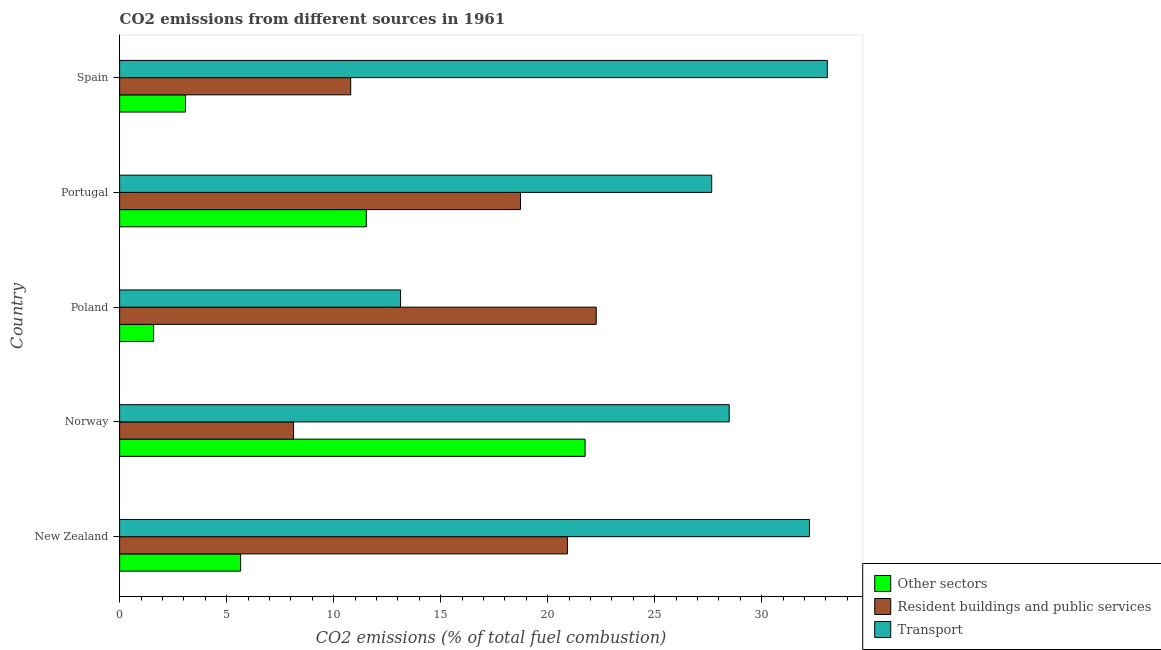How many different coloured bars are there?
Provide a succinct answer. 3. How many groups of bars are there?
Give a very brief answer. 5. How many bars are there on the 1st tick from the bottom?
Your response must be concise. 3. What is the label of the 1st group of bars from the top?
Provide a short and direct response. Spain. What is the percentage of co2 emissions from transport in Portugal?
Offer a terse response. 27.67. Across all countries, what is the maximum percentage of co2 emissions from resident buildings and public services?
Offer a very short reply. 22.27. Across all countries, what is the minimum percentage of co2 emissions from resident buildings and public services?
Your response must be concise. 8.13. What is the total percentage of co2 emissions from other sectors in the graph?
Give a very brief answer. 43.6. What is the difference between the percentage of co2 emissions from resident buildings and public services in New Zealand and that in Poland?
Provide a short and direct response. -1.35. What is the difference between the percentage of co2 emissions from resident buildings and public services in Norway and the percentage of co2 emissions from other sectors in Portugal?
Provide a short and direct response. -3.4. What is the average percentage of co2 emissions from resident buildings and public services per country?
Make the answer very short. 16.17. What is the difference between the percentage of co2 emissions from other sectors and percentage of co2 emissions from transport in Norway?
Give a very brief answer. -6.73. In how many countries, is the percentage of co2 emissions from transport greater than 4 %?
Provide a succinct answer. 5. Is the percentage of co2 emissions from other sectors in Norway less than that in Portugal?
Give a very brief answer. No. What is the difference between the highest and the second highest percentage of co2 emissions from other sectors?
Keep it short and to the point. 10.22. What is the difference between the highest and the lowest percentage of co2 emissions from transport?
Give a very brief answer. 19.94. What does the 3rd bar from the top in Norway represents?
Offer a terse response. Other sectors. What does the 3rd bar from the bottom in Spain represents?
Provide a short and direct response. Transport. What is the difference between two consecutive major ticks on the X-axis?
Your answer should be compact. 5. Are the values on the major ticks of X-axis written in scientific E-notation?
Keep it short and to the point. No. How many legend labels are there?
Provide a succinct answer. 3. What is the title of the graph?
Ensure brevity in your answer.  CO2 emissions from different sources in 1961. Does "Coal" appear as one of the legend labels in the graph?
Make the answer very short. No. What is the label or title of the X-axis?
Your response must be concise. CO2 emissions (% of total fuel combustion). What is the CO2 emissions (% of total fuel combustion) in Other sectors in New Zealand?
Offer a terse response. 5.66. What is the CO2 emissions (% of total fuel combustion) of Resident buildings and public services in New Zealand?
Make the answer very short. 20.92. What is the CO2 emissions (% of total fuel combustion) in Transport in New Zealand?
Your answer should be very brief. 32.23. What is the CO2 emissions (% of total fuel combustion) of Other sectors in Norway?
Your response must be concise. 21.75. What is the CO2 emissions (% of total fuel combustion) in Resident buildings and public services in Norway?
Provide a short and direct response. 8.13. What is the CO2 emissions (% of total fuel combustion) of Transport in Norway?
Your response must be concise. 28.48. What is the CO2 emissions (% of total fuel combustion) in Other sectors in Poland?
Your answer should be very brief. 1.59. What is the CO2 emissions (% of total fuel combustion) of Resident buildings and public services in Poland?
Provide a succinct answer. 22.27. What is the CO2 emissions (% of total fuel combustion) of Transport in Poland?
Offer a terse response. 13.13. What is the CO2 emissions (% of total fuel combustion) in Other sectors in Portugal?
Make the answer very short. 11.53. What is the CO2 emissions (% of total fuel combustion) of Resident buildings and public services in Portugal?
Give a very brief answer. 18.73. What is the CO2 emissions (% of total fuel combustion) of Transport in Portugal?
Ensure brevity in your answer.  27.67. What is the CO2 emissions (% of total fuel combustion) of Other sectors in Spain?
Provide a succinct answer. 3.08. What is the CO2 emissions (% of total fuel combustion) in Resident buildings and public services in Spain?
Offer a terse response. 10.8. What is the CO2 emissions (% of total fuel combustion) in Transport in Spain?
Give a very brief answer. 33.07. Across all countries, what is the maximum CO2 emissions (% of total fuel combustion) in Other sectors?
Provide a short and direct response. 21.75. Across all countries, what is the maximum CO2 emissions (% of total fuel combustion) in Resident buildings and public services?
Offer a terse response. 22.27. Across all countries, what is the maximum CO2 emissions (% of total fuel combustion) in Transport?
Offer a very short reply. 33.07. Across all countries, what is the minimum CO2 emissions (% of total fuel combustion) of Other sectors?
Ensure brevity in your answer.  1.59. Across all countries, what is the minimum CO2 emissions (% of total fuel combustion) of Resident buildings and public services?
Provide a short and direct response. 8.13. Across all countries, what is the minimum CO2 emissions (% of total fuel combustion) in Transport?
Provide a succinct answer. 13.13. What is the total CO2 emissions (% of total fuel combustion) of Other sectors in the graph?
Keep it short and to the point. 43.6. What is the total CO2 emissions (% of total fuel combustion) of Resident buildings and public services in the graph?
Offer a terse response. 80.85. What is the total CO2 emissions (% of total fuel combustion) in Transport in the graph?
Your answer should be compact. 134.58. What is the difference between the CO2 emissions (% of total fuel combustion) of Other sectors in New Zealand and that in Norway?
Offer a very short reply. -16.09. What is the difference between the CO2 emissions (% of total fuel combustion) in Resident buildings and public services in New Zealand and that in Norway?
Offer a very short reply. 12.8. What is the difference between the CO2 emissions (% of total fuel combustion) of Transport in New Zealand and that in Norway?
Keep it short and to the point. 3.75. What is the difference between the CO2 emissions (% of total fuel combustion) of Other sectors in New Zealand and that in Poland?
Provide a succinct answer. 4.07. What is the difference between the CO2 emissions (% of total fuel combustion) of Resident buildings and public services in New Zealand and that in Poland?
Offer a terse response. -1.35. What is the difference between the CO2 emissions (% of total fuel combustion) of Transport in New Zealand and that in Poland?
Keep it short and to the point. 19.11. What is the difference between the CO2 emissions (% of total fuel combustion) in Other sectors in New Zealand and that in Portugal?
Provide a short and direct response. -5.87. What is the difference between the CO2 emissions (% of total fuel combustion) of Resident buildings and public services in New Zealand and that in Portugal?
Keep it short and to the point. 2.19. What is the difference between the CO2 emissions (% of total fuel combustion) of Transport in New Zealand and that in Portugal?
Your answer should be very brief. 4.57. What is the difference between the CO2 emissions (% of total fuel combustion) of Other sectors in New Zealand and that in Spain?
Ensure brevity in your answer.  2.57. What is the difference between the CO2 emissions (% of total fuel combustion) of Resident buildings and public services in New Zealand and that in Spain?
Your answer should be compact. 10.13. What is the difference between the CO2 emissions (% of total fuel combustion) of Transport in New Zealand and that in Spain?
Ensure brevity in your answer.  -0.83. What is the difference between the CO2 emissions (% of total fuel combustion) of Other sectors in Norway and that in Poland?
Your answer should be compact. 20.16. What is the difference between the CO2 emissions (% of total fuel combustion) of Resident buildings and public services in Norway and that in Poland?
Give a very brief answer. -14.14. What is the difference between the CO2 emissions (% of total fuel combustion) of Transport in Norway and that in Poland?
Your response must be concise. 15.36. What is the difference between the CO2 emissions (% of total fuel combustion) in Other sectors in Norway and that in Portugal?
Make the answer very short. 10.22. What is the difference between the CO2 emissions (% of total fuel combustion) in Resident buildings and public services in Norway and that in Portugal?
Your answer should be very brief. -10.61. What is the difference between the CO2 emissions (% of total fuel combustion) in Transport in Norway and that in Portugal?
Your response must be concise. 0.82. What is the difference between the CO2 emissions (% of total fuel combustion) in Other sectors in Norway and that in Spain?
Your answer should be very brief. 18.67. What is the difference between the CO2 emissions (% of total fuel combustion) of Resident buildings and public services in Norway and that in Spain?
Offer a very short reply. -2.67. What is the difference between the CO2 emissions (% of total fuel combustion) in Transport in Norway and that in Spain?
Ensure brevity in your answer.  -4.58. What is the difference between the CO2 emissions (% of total fuel combustion) of Other sectors in Poland and that in Portugal?
Your answer should be compact. -9.94. What is the difference between the CO2 emissions (% of total fuel combustion) in Resident buildings and public services in Poland and that in Portugal?
Provide a succinct answer. 3.54. What is the difference between the CO2 emissions (% of total fuel combustion) of Transport in Poland and that in Portugal?
Offer a terse response. -14.54. What is the difference between the CO2 emissions (% of total fuel combustion) of Other sectors in Poland and that in Spain?
Ensure brevity in your answer.  -1.49. What is the difference between the CO2 emissions (% of total fuel combustion) in Resident buildings and public services in Poland and that in Spain?
Offer a very short reply. 11.47. What is the difference between the CO2 emissions (% of total fuel combustion) in Transport in Poland and that in Spain?
Your answer should be very brief. -19.94. What is the difference between the CO2 emissions (% of total fuel combustion) in Other sectors in Portugal and that in Spain?
Your response must be concise. 8.45. What is the difference between the CO2 emissions (% of total fuel combustion) in Resident buildings and public services in Portugal and that in Spain?
Ensure brevity in your answer.  7.93. What is the difference between the CO2 emissions (% of total fuel combustion) of Transport in Portugal and that in Spain?
Your answer should be compact. -5.4. What is the difference between the CO2 emissions (% of total fuel combustion) of Other sectors in New Zealand and the CO2 emissions (% of total fuel combustion) of Resident buildings and public services in Norway?
Offer a very short reply. -2.47. What is the difference between the CO2 emissions (% of total fuel combustion) of Other sectors in New Zealand and the CO2 emissions (% of total fuel combustion) of Transport in Norway?
Provide a succinct answer. -22.83. What is the difference between the CO2 emissions (% of total fuel combustion) in Resident buildings and public services in New Zealand and the CO2 emissions (% of total fuel combustion) in Transport in Norway?
Your answer should be very brief. -7.56. What is the difference between the CO2 emissions (% of total fuel combustion) in Other sectors in New Zealand and the CO2 emissions (% of total fuel combustion) in Resident buildings and public services in Poland?
Offer a terse response. -16.62. What is the difference between the CO2 emissions (% of total fuel combustion) in Other sectors in New Zealand and the CO2 emissions (% of total fuel combustion) in Transport in Poland?
Your answer should be compact. -7.47. What is the difference between the CO2 emissions (% of total fuel combustion) of Resident buildings and public services in New Zealand and the CO2 emissions (% of total fuel combustion) of Transport in Poland?
Make the answer very short. 7.8. What is the difference between the CO2 emissions (% of total fuel combustion) in Other sectors in New Zealand and the CO2 emissions (% of total fuel combustion) in Resident buildings and public services in Portugal?
Your answer should be compact. -13.08. What is the difference between the CO2 emissions (% of total fuel combustion) of Other sectors in New Zealand and the CO2 emissions (% of total fuel combustion) of Transport in Portugal?
Ensure brevity in your answer.  -22.01. What is the difference between the CO2 emissions (% of total fuel combustion) of Resident buildings and public services in New Zealand and the CO2 emissions (% of total fuel combustion) of Transport in Portugal?
Your answer should be very brief. -6.74. What is the difference between the CO2 emissions (% of total fuel combustion) in Other sectors in New Zealand and the CO2 emissions (% of total fuel combustion) in Resident buildings and public services in Spain?
Keep it short and to the point. -5.14. What is the difference between the CO2 emissions (% of total fuel combustion) of Other sectors in New Zealand and the CO2 emissions (% of total fuel combustion) of Transport in Spain?
Offer a very short reply. -27.41. What is the difference between the CO2 emissions (% of total fuel combustion) in Resident buildings and public services in New Zealand and the CO2 emissions (% of total fuel combustion) in Transport in Spain?
Provide a short and direct response. -12.14. What is the difference between the CO2 emissions (% of total fuel combustion) in Other sectors in Norway and the CO2 emissions (% of total fuel combustion) in Resident buildings and public services in Poland?
Offer a terse response. -0.52. What is the difference between the CO2 emissions (% of total fuel combustion) of Other sectors in Norway and the CO2 emissions (% of total fuel combustion) of Transport in Poland?
Give a very brief answer. 8.62. What is the difference between the CO2 emissions (% of total fuel combustion) of Resident buildings and public services in Norway and the CO2 emissions (% of total fuel combustion) of Transport in Poland?
Keep it short and to the point. -5. What is the difference between the CO2 emissions (% of total fuel combustion) of Other sectors in Norway and the CO2 emissions (% of total fuel combustion) of Resident buildings and public services in Portugal?
Offer a very short reply. 3.02. What is the difference between the CO2 emissions (% of total fuel combustion) of Other sectors in Norway and the CO2 emissions (% of total fuel combustion) of Transport in Portugal?
Your answer should be very brief. -5.92. What is the difference between the CO2 emissions (% of total fuel combustion) of Resident buildings and public services in Norway and the CO2 emissions (% of total fuel combustion) of Transport in Portugal?
Offer a terse response. -19.54. What is the difference between the CO2 emissions (% of total fuel combustion) in Other sectors in Norway and the CO2 emissions (% of total fuel combustion) in Resident buildings and public services in Spain?
Keep it short and to the point. 10.95. What is the difference between the CO2 emissions (% of total fuel combustion) of Other sectors in Norway and the CO2 emissions (% of total fuel combustion) of Transport in Spain?
Keep it short and to the point. -11.32. What is the difference between the CO2 emissions (% of total fuel combustion) of Resident buildings and public services in Norway and the CO2 emissions (% of total fuel combustion) of Transport in Spain?
Your answer should be very brief. -24.94. What is the difference between the CO2 emissions (% of total fuel combustion) in Other sectors in Poland and the CO2 emissions (% of total fuel combustion) in Resident buildings and public services in Portugal?
Your response must be concise. -17.14. What is the difference between the CO2 emissions (% of total fuel combustion) of Other sectors in Poland and the CO2 emissions (% of total fuel combustion) of Transport in Portugal?
Keep it short and to the point. -26.08. What is the difference between the CO2 emissions (% of total fuel combustion) in Resident buildings and public services in Poland and the CO2 emissions (% of total fuel combustion) in Transport in Portugal?
Your answer should be compact. -5.4. What is the difference between the CO2 emissions (% of total fuel combustion) in Other sectors in Poland and the CO2 emissions (% of total fuel combustion) in Resident buildings and public services in Spain?
Provide a short and direct response. -9.21. What is the difference between the CO2 emissions (% of total fuel combustion) of Other sectors in Poland and the CO2 emissions (% of total fuel combustion) of Transport in Spain?
Your answer should be compact. -31.48. What is the difference between the CO2 emissions (% of total fuel combustion) of Resident buildings and public services in Poland and the CO2 emissions (% of total fuel combustion) of Transport in Spain?
Make the answer very short. -10.8. What is the difference between the CO2 emissions (% of total fuel combustion) in Other sectors in Portugal and the CO2 emissions (% of total fuel combustion) in Resident buildings and public services in Spain?
Provide a succinct answer. 0.73. What is the difference between the CO2 emissions (% of total fuel combustion) in Other sectors in Portugal and the CO2 emissions (% of total fuel combustion) in Transport in Spain?
Offer a very short reply. -21.54. What is the difference between the CO2 emissions (% of total fuel combustion) in Resident buildings and public services in Portugal and the CO2 emissions (% of total fuel combustion) in Transport in Spain?
Provide a succinct answer. -14.34. What is the average CO2 emissions (% of total fuel combustion) in Other sectors per country?
Provide a short and direct response. 8.72. What is the average CO2 emissions (% of total fuel combustion) of Resident buildings and public services per country?
Keep it short and to the point. 16.17. What is the average CO2 emissions (% of total fuel combustion) in Transport per country?
Offer a terse response. 26.92. What is the difference between the CO2 emissions (% of total fuel combustion) of Other sectors and CO2 emissions (% of total fuel combustion) of Resident buildings and public services in New Zealand?
Ensure brevity in your answer.  -15.27. What is the difference between the CO2 emissions (% of total fuel combustion) in Other sectors and CO2 emissions (% of total fuel combustion) in Transport in New Zealand?
Provide a succinct answer. -26.58. What is the difference between the CO2 emissions (% of total fuel combustion) of Resident buildings and public services and CO2 emissions (% of total fuel combustion) of Transport in New Zealand?
Give a very brief answer. -11.31. What is the difference between the CO2 emissions (% of total fuel combustion) of Other sectors and CO2 emissions (% of total fuel combustion) of Resident buildings and public services in Norway?
Make the answer very short. 13.62. What is the difference between the CO2 emissions (% of total fuel combustion) of Other sectors and CO2 emissions (% of total fuel combustion) of Transport in Norway?
Ensure brevity in your answer.  -6.73. What is the difference between the CO2 emissions (% of total fuel combustion) in Resident buildings and public services and CO2 emissions (% of total fuel combustion) in Transport in Norway?
Provide a short and direct response. -20.36. What is the difference between the CO2 emissions (% of total fuel combustion) in Other sectors and CO2 emissions (% of total fuel combustion) in Resident buildings and public services in Poland?
Provide a succinct answer. -20.68. What is the difference between the CO2 emissions (% of total fuel combustion) in Other sectors and CO2 emissions (% of total fuel combustion) in Transport in Poland?
Your response must be concise. -11.54. What is the difference between the CO2 emissions (% of total fuel combustion) in Resident buildings and public services and CO2 emissions (% of total fuel combustion) in Transport in Poland?
Your response must be concise. 9.14. What is the difference between the CO2 emissions (% of total fuel combustion) in Other sectors and CO2 emissions (% of total fuel combustion) in Resident buildings and public services in Portugal?
Provide a succinct answer. -7.2. What is the difference between the CO2 emissions (% of total fuel combustion) in Other sectors and CO2 emissions (% of total fuel combustion) in Transport in Portugal?
Provide a short and direct response. -16.14. What is the difference between the CO2 emissions (% of total fuel combustion) in Resident buildings and public services and CO2 emissions (% of total fuel combustion) in Transport in Portugal?
Ensure brevity in your answer.  -8.93. What is the difference between the CO2 emissions (% of total fuel combustion) of Other sectors and CO2 emissions (% of total fuel combustion) of Resident buildings and public services in Spain?
Ensure brevity in your answer.  -7.72. What is the difference between the CO2 emissions (% of total fuel combustion) in Other sectors and CO2 emissions (% of total fuel combustion) in Transport in Spain?
Your response must be concise. -29.99. What is the difference between the CO2 emissions (% of total fuel combustion) of Resident buildings and public services and CO2 emissions (% of total fuel combustion) of Transport in Spain?
Your answer should be compact. -22.27. What is the ratio of the CO2 emissions (% of total fuel combustion) of Other sectors in New Zealand to that in Norway?
Your answer should be compact. 0.26. What is the ratio of the CO2 emissions (% of total fuel combustion) of Resident buildings and public services in New Zealand to that in Norway?
Give a very brief answer. 2.57. What is the ratio of the CO2 emissions (% of total fuel combustion) in Transport in New Zealand to that in Norway?
Make the answer very short. 1.13. What is the ratio of the CO2 emissions (% of total fuel combustion) of Other sectors in New Zealand to that in Poland?
Ensure brevity in your answer.  3.56. What is the ratio of the CO2 emissions (% of total fuel combustion) of Resident buildings and public services in New Zealand to that in Poland?
Offer a terse response. 0.94. What is the ratio of the CO2 emissions (% of total fuel combustion) of Transport in New Zealand to that in Poland?
Give a very brief answer. 2.46. What is the ratio of the CO2 emissions (% of total fuel combustion) in Other sectors in New Zealand to that in Portugal?
Your answer should be compact. 0.49. What is the ratio of the CO2 emissions (% of total fuel combustion) in Resident buildings and public services in New Zealand to that in Portugal?
Provide a short and direct response. 1.12. What is the ratio of the CO2 emissions (% of total fuel combustion) in Transport in New Zealand to that in Portugal?
Keep it short and to the point. 1.17. What is the ratio of the CO2 emissions (% of total fuel combustion) in Other sectors in New Zealand to that in Spain?
Give a very brief answer. 1.84. What is the ratio of the CO2 emissions (% of total fuel combustion) in Resident buildings and public services in New Zealand to that in Spain?
Make the answer very short. 1.94. What is the ratio of the CO2 emissions (% of total fuel combustion) of Transport in New Zealand to that in Spain?
Give a very brief answer. 0.97. What is the ratio of the CO2 emissions (% of total fuel combustion) in Other sectors in Norway to that in Poland?
Make the answer very short. 13.68. What is the ratio of the CO2 emissions (% of total fuel combustion) in Resident buildings and public services in Norway to that in Poland?
Give a very brief answer. 0.36. What is the ratio of the CO2 emissions (% of total fuel combustion) in Transport in Norway to that in Poland?
Make the answer very short. 2.17. What is the ratio of the CO2 emissions (% of total fuel combustion) of Other sectors in Norway to that in Portugal?
Make the answer very short. 1.89. What is the ratio of the CO2 emissions (% of total fuel combustion) of Resident buildings and public services in Norway to that in Portugal?
Your answer should be compact. 0.43. What is the ratio of the CO2 emissions (% of total fuel combustion) of Transport in Norway to that in Portugal?
Keep it short and to the point. 1.03. What is the ratio of the CO2 emissions (% of total fuel combustion) in Other sectors in Norway to that in Spain?
Provide a short and direct response. 7.06. What is the ratio of the CO2 emissions (% of total fuel combustion) of Resident buildings and public services in Norway to that in Spain?
Your answer should be very brief. 0.75. What is the ratio of the CO2 emissions (% of total fuel combustion) of Transport in Norway to that in Spain?
Give a very brief answer. 0.86. What is the ratio of the CO2 emissions (% of total fuel combustion) of Other sectors in Poland to that in Portugal?
Offer a very short reply. 0.14. What is the ratio of the CO2 emissions (% of total fuel combustion) of Resident buildings and public services in Poland to that in Portugal?
Make the answer very short. 1.19. What is the ratio of the CO2 emissions (% of total fuel combustion) of Transport in Poland to that in Portugal?
Offer a terse response. 0.47. What is the ratio of the CO2 emissions (% of total fuel combustion) of Other sectors in Poland to that in Spain?
Your answer should be very brief. 0.52. What is the ratio of the CO2 emissions (% of total fuel combustion) in Resident buildings and public services in Poland to that in Spain?
Your answer should be very brief. 2.06. What is the ratio of the CO2 emissions (% of total fuel combustion) in Transport in Poland to that in Spain?
Provide a short and direct response. 0.4. What is the ratio of the CO2 emissions (% of total fuel combustion) in Other sectors in Portugal to that in Spain?
Offer a very short reply. 3.74. What is the ratio of the CO2 emissions (% of total fuel combustion) in Resident buildings and public services in Portugal to that in Spain?
Make the answer very short. 1.73. What is the ratio of the CO2 emissions (% of total fuel combustion) in Transport in Portugal to that in Spain?
Keep it short and to the point. 0.84. What is the difference between the highest and the second highest CO2 emissions (% of total fuel combustion) of Other sectors?
Give a very brief answer. 10.22. What is the difference between the highest and the second highest CO2 emissions (% of total fuel combustion) of Resident buildings and public services?
Provide a short and direct response. 1.35. What is the difference between the highest and the second highest CO2 emissions (% of total fuel combustion) of Transport?
Provide a succinct answer. 0.83. What is the difference between the highest and the lowest CO2 emissions (% of total fuel combustion) of Other sectors?
Offer a very short reply. 20.16. What is the difference between the highest and the lowest CO2 emissions (% of total fuel combustion) in Resident buildings and public services?
Offer a terse response. 14.14. What is the difference between the highest and the lowest CO2 emissions (% of total fuel combustion) of Transport?
Your answer should be compact. 19.94. 